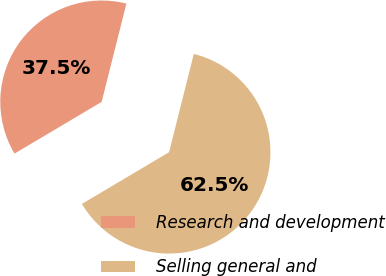<chart> <loc_0><loc_0><loc_500><loc_500><pie_chart><fcel>Research and development<fcel>Selling general and<nl><fcel>37.45%<fcel>62.55%<nl></chart> 